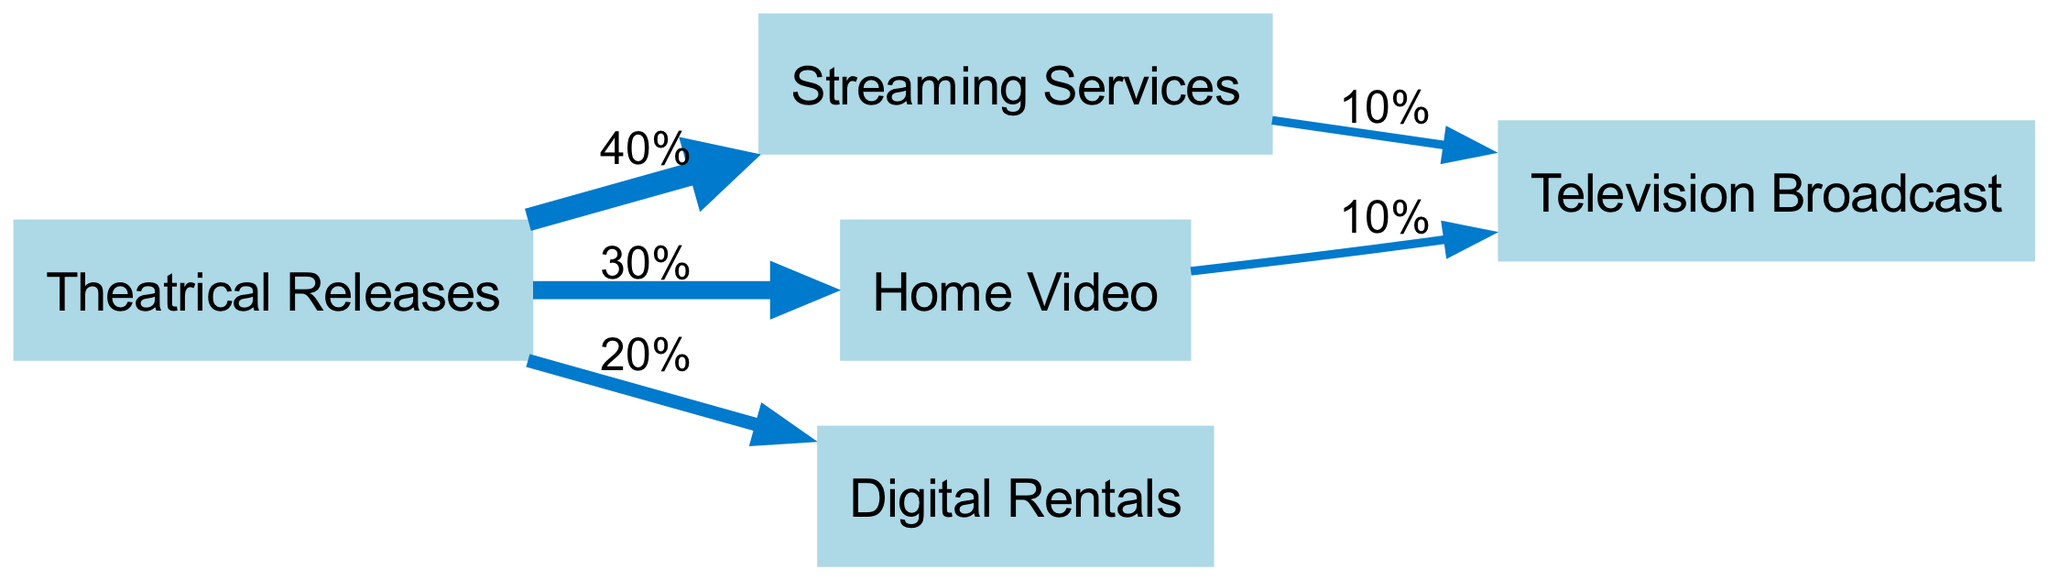What are the five distribution channels shown in the diagram? The diagram displays five nodes representing different film distribution channels: Theatrical Releases, Streaming Services, Home Video, Digital Rentals, and Television Broadcast.
Answer: Theatrical Releases, Streaming Services, Home Video, Digital Rentals, Television Broadcast What percentage of revenue from Theatrical Releases goes to Streaming Services? The diagram indicates a direct flow from Theatrical Releases to Streaming Services with a labeled value of 40%. Thus, 40% of revenue from Theatrical Releases is directed to Streaming Services.
Answer: 40% How many total links are present in the diagram? By counting the directional flows (edges) represented in the diagram, there are a total of five links connecting the various nodes.
Answer: 5 What is the total revenue percentage flowing into Television Broadcast? To determine the total percentage flowing into Television Broadcast, one must sum the links coming into it: 10% from Streaming Services and 10% from Home Video. Therefore, the total is 10% + 10% = 20%.
Answer: 20% Which distribution channel receives the highest contribution from Theatrical Releases? By analyzing the connecting links, Theatrical Releases has three outbound flows with 40% to Streaming Services, 30% to Home Video, and 20% to Digital Rentals. The highest contribution is to Streaming Services with 40%.
Answer: Streaming Services What is the relationship between Digital Rentals and Television Broadcast? The diagram does not show any direct link from Digital Rentals to Television Broadcast. Thus, there is no revenue contribution from Digital Rentals to Television Broadcast.
Answer: No relationship Which channel receives a 10% contribution from both Streaming Services and Home Video? The diagram shows a flow of 10% from both Streaming Services and Home Video directed towards Television Broadcast, indicating that this channel receives contributions from both of them.
Answer: Television Broadcast What is the least revenue contribution percentage from Theatrical Releases? Looking at the links from Theatrical Releases, the least contribution is directed towards Digital Rentals at 20%.
Answer: 20% 